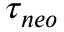<formula> <loc_0><loc_0><loc_500><loc_500>\tau _ { n e o }</formula> 